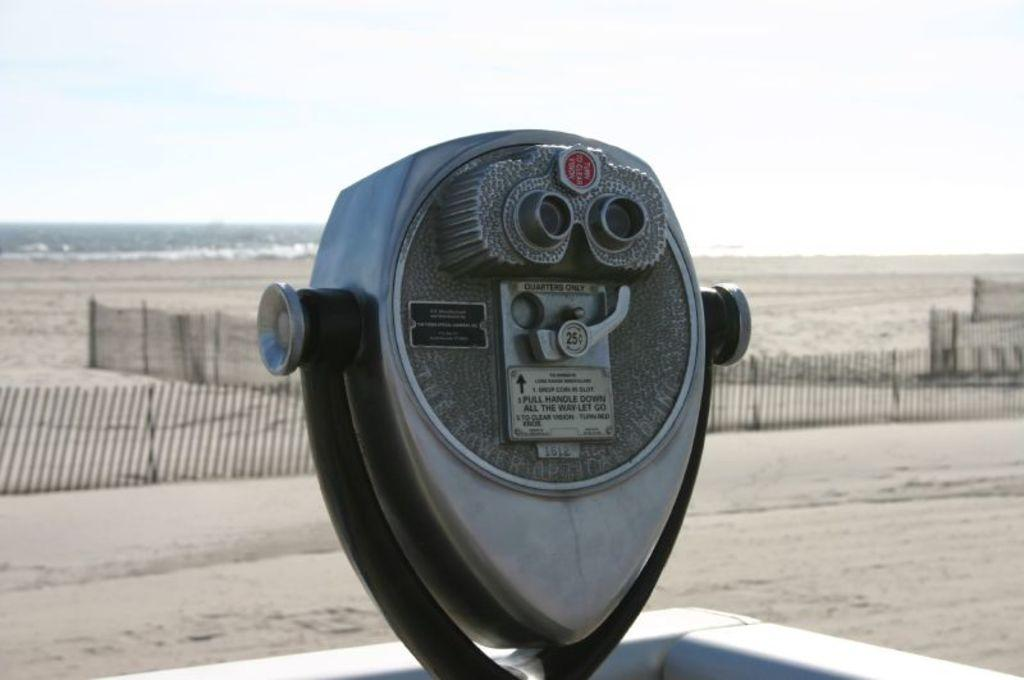What is the main object in the picture? There is an iron object in the picture. What is attached to the iron object? There are two small boards on the iron object. What are the small boards held together with? There are screws on the iron object. What can be seen in the background of the picture? There is a fence and the sky visible in the background of the picture, and it appears to be the sea in the background. How many beds can be seen in the picture? There are no beds present in the picture. What type of bird is flying over the sea in the background of the picture? There is no bird visible in the picture; it only shows an iron object with two small boards and the sea in the background. 